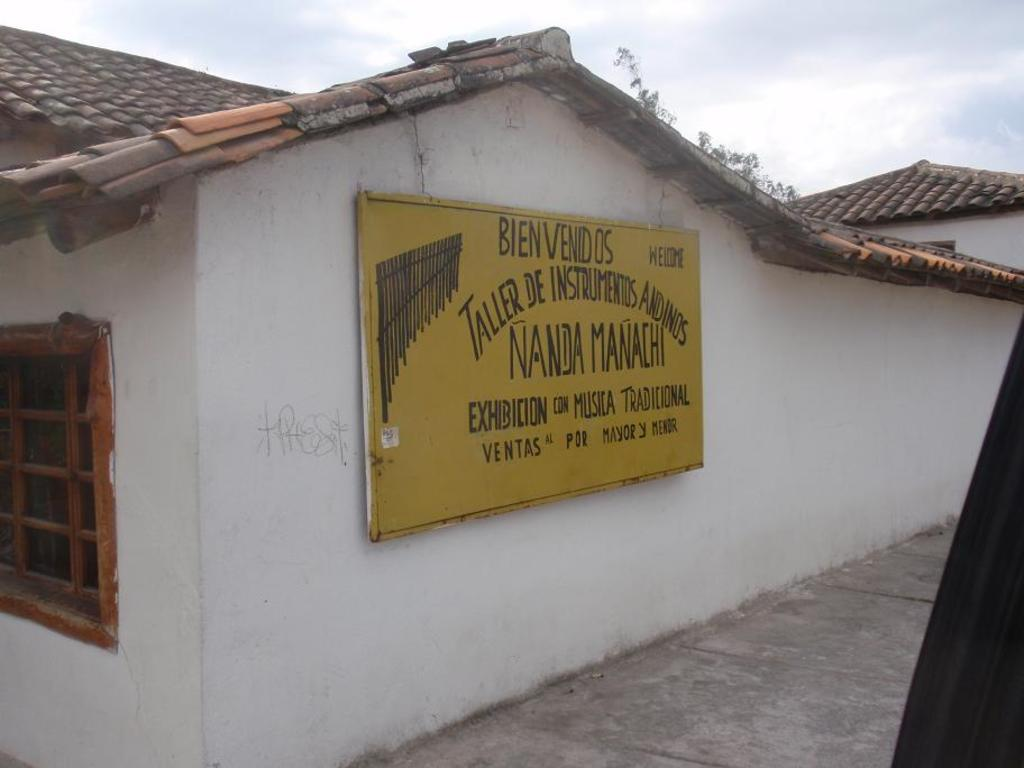<image>
Give a short and clear explanation of the subsequent image. A yellow sign that says bien venidos on the side of a building 